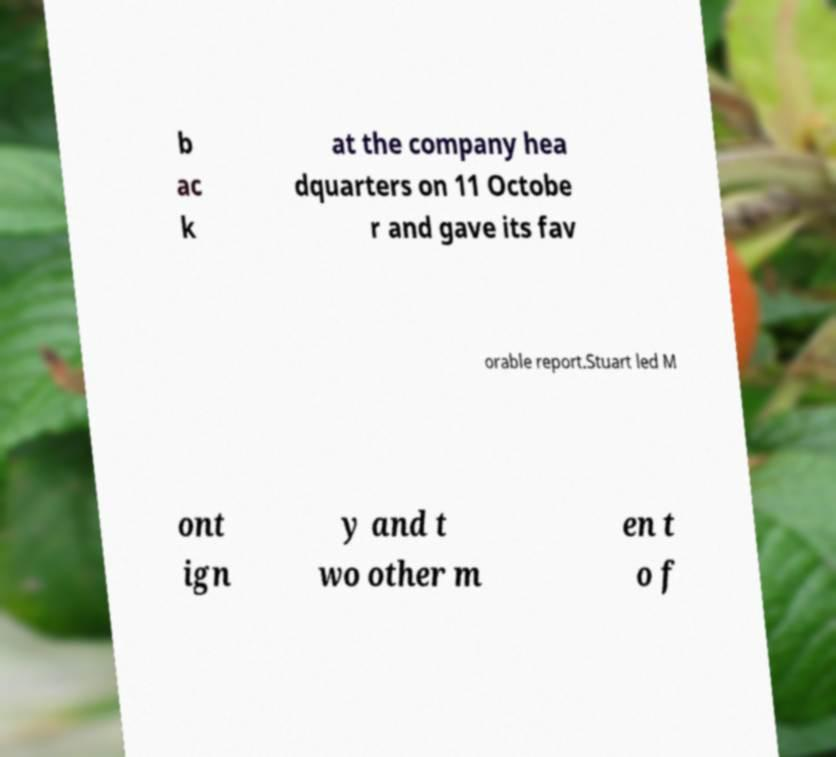I need the written content from this picture converted into text. Can you do that? b ac k at the company hea dquarters on 11 Octobe r and gave its fav orable report.Stuart led M ont ign y and t wo other m en t o f 